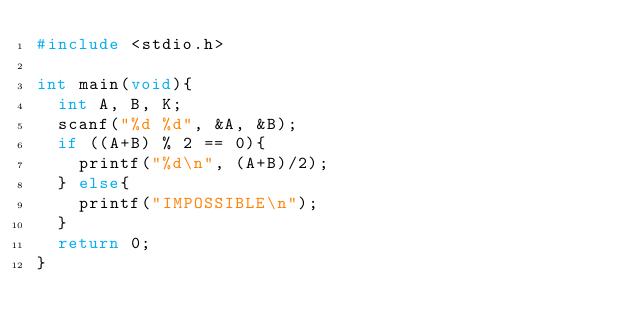Convert code to text. <code><loc_0><loc_0><loc_500><loc_500><_C_>#include <stdio.h>

int main(void){
	int A, B, K;
	scanf("%d %d", &A, &B);
	if ((A+B) % 2 == 0){
		printf("%d\n", (A+B)/2);
	} else{
		printf("IMPOSSIBLE\n");
	}
	return 0;
}
</code> 